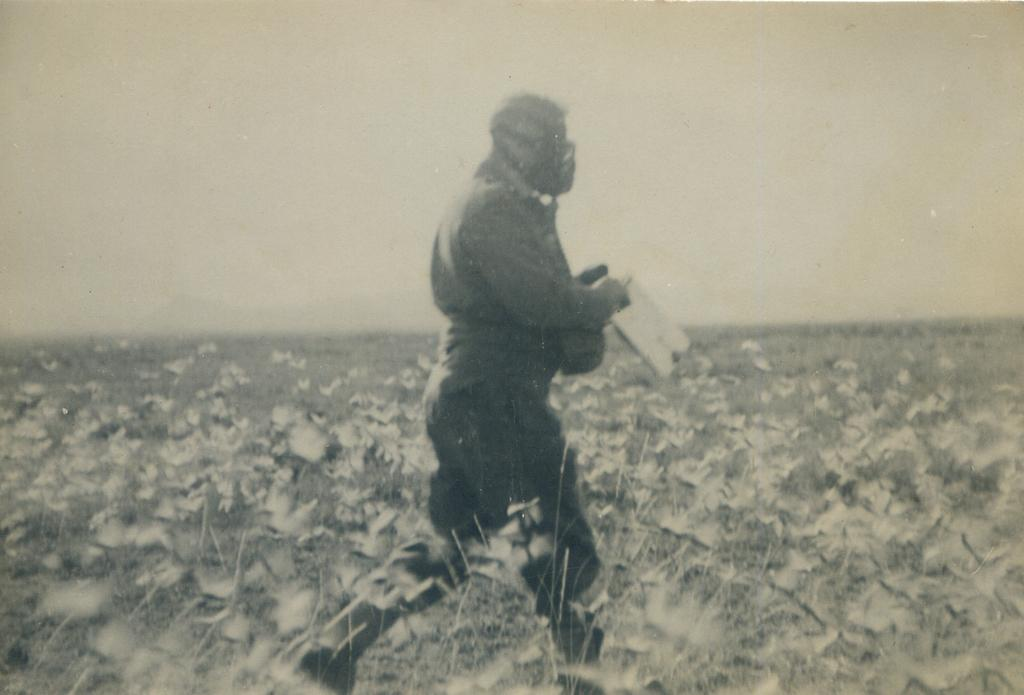What is the person in the image doing? There is a person walking in the image. What is the person holding while walking? The person is holding an object. What type of vegetation can be seen in the image? There are plants in the image. What is the texture of the person's breath in the image? There is no information about the person's breath in the image, so it is not possible to determine its texture. 